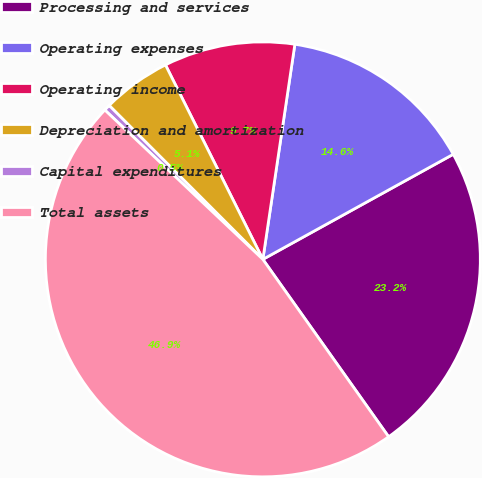Convert chart to OTSL. <chart><loc_0><loc_0><loc_500><loc_500><pie_chart><fcel>Processing and services<fcel>Operating expenses<fcel>Operating income<fcel>Depreciation and amortization<fcel>Capital expenditures<fcel>Total assets<nl><fcel>23.21%<fcel>14.62%<fcel>9.74%<fcel>5.1%<fcel>0.46%<fcel>46.86%<nl></chart> 